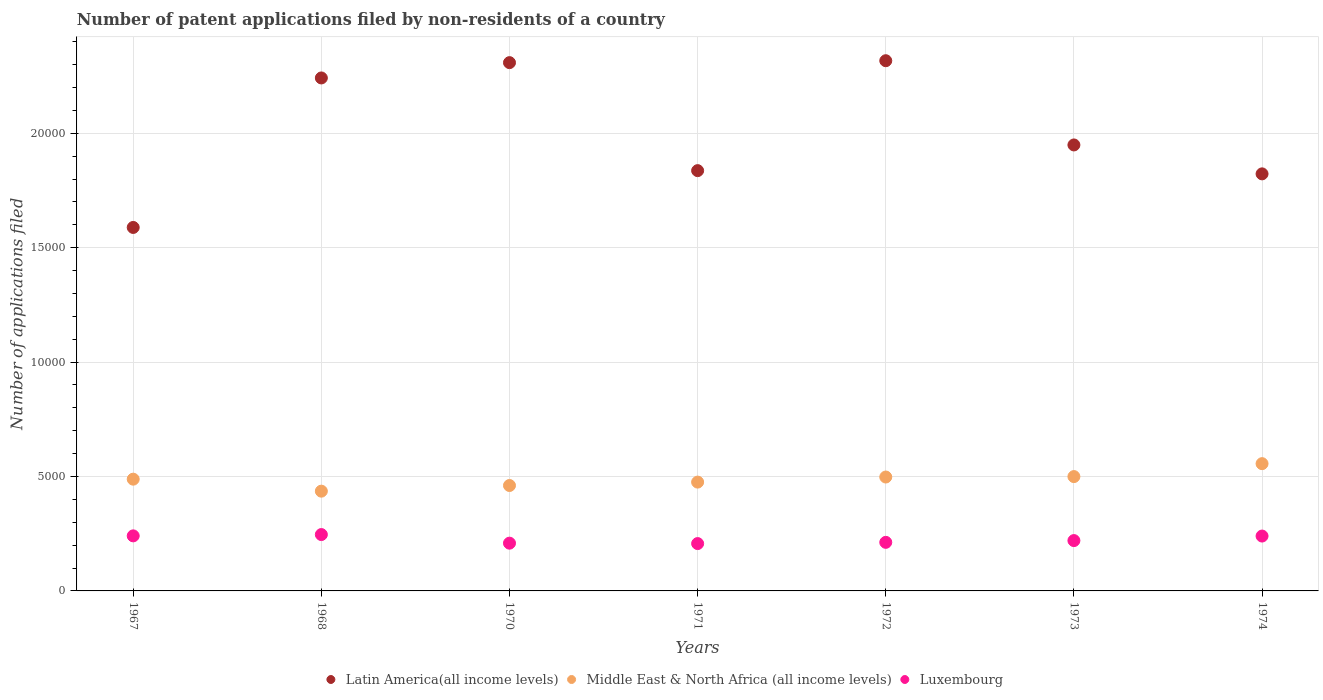Is the number of dotlines equal to the number of legend labels?
Ensure brevity in your answer.  Yes. What is the number of applications filed in Latin America(all income levels) in 1974?
Your answer should be very brief. 1.82e+04. Across all years, what is the maximum number of applications filed in Luxembourg?
Keep it short and to the point. 2463. Across all years, what is the minimum number of applications filed in Luxembourg?
Your answer should be very brief. 2069. In which year was the number of applications filed in Middle East & North Africa (all income levels) maximum?
Make the answer very short. 1974. In which year was the number of applications filed in Luxembourg minimum?
Provide a short and direct response. 1971. What is the total number of applications filed in Luxembourg in the graph?
Ensure brevity in your answer.  1.57e+04. What is the difference between the number of applications filed in Middle East & North Africa (all income levels) in 1973 and that in 1974?
Offer a terse response. -565. What is the difference between the number of applications filed in Luxembourg in 1967 and the number of applications filed in Middle East & North Africa (all income levels) in 1972?
Your answer should be very brief. -2572. What is the average number of applications filed in Middle East & North Africa (all income levels) per year?
Make the answer very short. 4877.71. In the year 1970, what is the difference between the number of applications filed in Middle East & North Africa (all income levels) and number of applications filed in Latin America(all income levels)?
Give a very brief answer. -1.85e+04. In how many years, is the number of applications filed in Latin America(all income levels) greater than 14000?
Your answer should be very brief. 7. What is the ratio of the number of applications filed in Luxembourg in 1967 to that in 1972?
Offer a terse response. 1.13. What is the difference between the highest and the lowest number of applications filed in Middle East & North Africa (all income levels)?
Offer a very short reply. 1202. Is it the case that in every year, the sum of the number of applications filed in Latin America(all income levels) and number of applications filed in Middle East & North Africa (all income levels)  is greater than the number of applications filed in Luxembourg?
Keep it short and to the point. Yes. Is the number of applications filed in Latin America(all income levels) strictly less than the number of applications filed in Middle East & North Africa (all income levels) over the years?
Your response must be concise. No. What is the difference between two consecutive major ticks on the Y-axis?
Your answer should be very brief. 5000. Are the values on the major ticks of Y-axis written in scientific E-notation?
Keep it short and to the point. No. Does the graph contain any zero values?
Make the answer very short. No. Where does the legend appear in the graph?
Your answer should be very brief. Bottom center. How many legend labels are there?
Your response must be concise. 3. What is the title of the graph?
Your answer should be compact. Number of patent applications filed by non-residents of a country. What is the label or title of the X-axis?
Offer a terse response. Years. What is the label or title of the Y-axis?
Offer a very short reply. Number of applications filed. What is the Number of applications filed in Latin America(all income levels) in 1967?
Ensure brevity in your answer.  1.59e+04. What is the Number of applications filed in Middle East & North Africa (all income levels) in 1967?
Offer a very short reply. 4884. What is the Number of applications filed of Luxembourg in 1967?
Offer a very short reply. 2406. What is the Number of applications filed in Latin America(all income levels) in 1968?
Give a very brief answer. 2.24e+04. What is the Number of applications filed in Middle East & North Africa (all income levels) in 1968?
Keep it short and to the point. 4360. What is the Number of applications filed of Luxembourg in 1968?
Provide a succinct answer. 2463. What is the Number of applications filed of Latin America(all income levels) in 1970?
Provide a short and direct response. 2.31e+04. What is the Number of applications filed of Middle East & North Africa (all income levels) in 1970?
Your answer should be compact. 4607. What is the Number of applications filed in Luxembourg in 1970?
Offer a terse response. 2087. What is the Number of applications filed of Latin America(all income levels) in 1971?
Offer a terse response. 1.84e+04. What is the Number of applications filed in Middle East & North Africa (all income levels) in 1971?
Provide a short and direct response. 4756. What is the Number of applications filed of Luxembourg in 1971?
Provide a short and direct response. 2069. What is the Number of applications filed of Latin America(all income levels) in 1972?
Offer a very short reply. 2.32e+04. What is the Number of applications filed in Middle East & North Africa (all income levels) in 1972?
Your answer should be compact. 4978. What is the Number of applications filed of Luxembourg in 1972?
Your answer should be compact. 2123. What is the Number of applications filed of Latin America(all income levels) in 1973?
Give a very brief answer. 1.95e+04. What is the Number of applications filed of Middle East & North Africa (all income levels) in 1973?
Your answer should be very brief. 4997. What is the Number of applications filed of Luxembourg in 1973?
Provide a short and direct response. 2200. What is the Number of applications filed of Latin America(all income levels) in 1974?
Keep it short and to the point. 1.82e+04. What is the Number of applications filed in Middle East & North Africa (all income levels) in 1974?
Give a very brief answer. 5562. What is the Number of applications filed in Luxembourg in 1974?
Provide a succinct answer. 2398. Across all years, what is the maximum Number of applications filed in Latin America(all income levels)?
Your answer should be very brief. 2.32e+04. Across all years, what is the maximum Number of applications filed in Middle East & North Africa (all income levels)?
Make the answer very short. 5562. Across all years, what is the maximum Number of applications filed in Luxembourg?
Your answer should be compact. 2463. Across all years, what is the minimum Number of applications filed of Latin America(all income levels)?
Ensure brevity in your answer.  1.59e+04. Across all years, what is the minimum Number of applications filed of Middle East & North Africa (all income levels)?
Give a very brief answer. 4360. Across all years, what is the minimum Number of applications filed in Luxembourg?
Your response must be concise. 2069. What is the total Number of applications filed in Latin America(all income levels) in the graph?
Provide a short and direct response. 1.41e+05. What is the total Number of applications filed in Middle East & North Africa (all income levels) in the graph?
Keep it short and to the point. 3.41e+04. What is the total Number of applications filed of Luxembourg in the graph?
Offer a terse response. 1.57e+04. What is the difference between the Number of applications filed of Latin America(all income levels) in 1967 and that in 1968?
Keep it short and to the point. -6534. What is the difference between the Number of applications filed of Middle East & North Africa (all income levels) in 1967 and that in 1968?
Provide a short and direct response. 524. What is the difference between the Number of applications filed in Luxembourg in 1967 and that in 1968?
Offer a very short reply. -57. What is the difference between the Number of applications filed of Latin America(all income levels) in 1967 and that in 1970?
Ensure brevity in your answer.  -7203. What is the difference between the Number of applications filed in Middle East & North Africa (all income levels) in 1967 and that in 1970?
Make the answer very short. 277. What is the difference between the Number of applications filed in Luxembourg in 1967 and that in 1970?
Offer a terse response. 319. What is the difference between the Number of applications filed in Latin America(all income levels) in 1967 and that in 1971?
Your response must be concise. -2483. What is the difference between the Number of applications filed in Middle East & North Africa (all income levels) in 1967 and that in 1971?
Give a very brief answer. 128. What is the difference between the Number of applications filed in Luxembourg in 1967 and that in 1971?
Ensure brevity in your answer.  337. What is the difference between the Number of applications filed in Latin America(all income levels) in 1967 and that in 1972?
Make the answer very short. -7287. What is the difference between the Number of applications filed in Middle East & North Africa (all income levels) in 1967 and that in 1972?
Ensure brevity in your answer.  -94. What is the difference between the Number of applications filed of Luxembourg in 1967 and that in 1972?
Ensure brevity in your answer.  283. What is the difference between the Number of applications filed of Latin America(all income levels) in 1967 and that in 1973?
Give a very brief answer. -3606. What is the difference between the Number of applications filed in Middle East & North Africa (all income levels) in 1967 and that in 1973?
Your answer should be very brief. -113. What is the difference between the Number of applications filed in Luxembourg in 1967 and that in 1973?
Provide a short and direct response. 206. What is the difference between the Number of applications filed in Latin America(all income levels) in 1967 and that in 1974?
Keep it short and to the point. -2342. What is the difference between the Number of applications filed of Middle East & North Africa (all income levels) in 1967 and that in 1974?
Keep it short and to the point. -678. What is the difference between the Number of applications filed in Latin America(all income levels) in 1968 and that in 1970?
Ensure brevity in your answer.  -669. What is the difference between the Number of applications filed in Middle East & North Africa (all income levels) in 1968 and that in 1970?
Provide a short and direct response. -247. What is the difference between the Number of applications filed of Luxembourg in 1968 and that in 1970?
Provide a short and direct response. 376. What is the difference between the Number of applications filed in Latin America(all income levels) in 1968 and that in 1971?
Provide a short and direct response. 4051. What is the difference between the Number of applications filed of Middle East & North Africa (all income levels) in 1968 and that in 1971?
Give a very brief answer. -396. What is the difference between the Number of applications filed in Luxembourg in 1968 and that in 1971?
Provide a short and direct response. 394. What is the difference between the Number of applications filed of Latin America(all income levels) in 1968 and that in 1972?
Provide a succinct answer. -753. What is the difference between the Number of applications filed in Middle East & North Africa (all income levels) in 1968 and that in 1972?
Provide a succinct answer. -618. What is the difference between the Number of applications filed of Luxembourg in 1968 and that in 1972?
Ensure brevity in your answer.  340. What is the difference between the Number of applications filed of Latin America(all income levels) in 1968 and that in 1973?
Your answer should be compact. 2928. What is the difference between the Number of applications filed in Middle East & North Africa (all income levels) in 1968 and that in 1973?
Make the answer very short. -637. What is the difference between the Number of applications filed in Luxembourg in 1968 and that in 1973?
Your answer should be compact. 263. What is the difference between the Number of applications filed of Latin America(all income levels) in 1968 and that in 1974?
Make the answer very short. 4192. What is the difference between the Number of applications filed of Middle East & North Africa (all income levels) in 1968 and that in 1974?
Provide a short and direct response. -1202. What is the difference between the Number of applications filed of Luxembourg in 1968 and that in 1974?
Give a very brief answer. 65. What is the difference between the Number of applications filed in Latin America(all income levels) in 1970 and that in 1971?
Give a very brief answer. 4720. What is the difference between the Number of applications filed of Middle East & North Africa (all income levels) in 1970 and that in 1971?
Provide a short and direct response. -149. What is the difference between the Number of applications filed in Luxembourg in 1970 and that in 1971?
Your answer should be very brief. 18. What is the difference between the Number of applications filed in Latin America(all income levels) in 1970 and that in 1972?
Your answer should be very brief. -84. What is the difference between the Number of applications filed in Middle East & North Africa (all income levels) in 1970 and that in 1972?
Make the answer very short. -371. What is the difference between the Number of applications filed in Luxembourg in 1970 and that in 1972?
Offer a terse response. -36. What is the difference between the Number of applications filed in Latin America(all income levels) in 1970 and that in 1973?
Give a very brief answer. 3597. What is the difference between the Number of applications filed of Middle East & North Africa (all income levels) in 1970 and that in 1973?
Give a very brief answer. -390. What is the difference between the Number of applications filed of Luxembourg in 1970 and that in 1973?
Your response must be concise. -113. What is the difference between the Number of applications filed of Latin America(all income levels) in 1970 and that in 1974?
Ensure brevity in your answer.  4861. What is the difference between the Number of applications filed in Middle East & North Africa (all income levels) in 1970 and that in 1974?
Your response must be concise. -955. What is the difference between the Number of applications filed of Luxembourg in 1970 and that in 1974?
Your answer should be compact. -311. What is the difference between the Number of applications filed in Latin America(all income levels) in 1971 and that in 1972?
Give a very brief answer. -4804. What is the difference between the Number of applications filed in Middle East & North Africa (all income levels) in 1971 and that in 1972?
Offer a terse response. -222. What is the difference between the Number of applications filed of Luxembourg in 1971 and that in 1972?
Provide a short and direct response. -54. What is the difference between the Number of applications filed of Latin America(all income levels) in 1971 and that in 1973?
Give a very brief answer. -1123. What is the difference between the Number of applications filed in Middle East & North Africa (all income levels) in 1971 and that in 1973?
Keep it short and to the point. -241. What is the difference between the Number of applications filed in Luxembourg in 1971 and that in 1973?
Offer a very short reply. -131. What is the difference between the Number of applications filed in Latin America(all income levels) in 1971 and that in 1974?
Your answer should be compact. 141. What is the difference between the Number of applications filed in Middle East & North Africa (all income levels) in 1971 and that in 1974?
Offer a very short reply. -806. What is the difference between the Number of applications filed of Luxembourg in 1971 and that in 1974?
Make the answer very short. -329. What is the difference between the Number of applications filed of Latin America(all income levels) in 1972 and that in 1973?
Make the answer very short. 3681. What is the difference between the Number of applications filed of Middle East & North Africa (all income levels) in 1972 and that in 1973?
Make the answer very short. -19. What is the difference between the Number of applications filed of Luxembourg in 1972 and that in 1973?
Give a very brief answer. -77. What is the difference between the Number of applications filed of Latin America(all income levels) in 1972 and that in 1974?
Make the answer very short. 4945. What is the difference between the Number of applications filed of Middle East & North Africa (all income levels) in 1972 and that in 1974?
Offer a very short reply. -584. What is the difference between the Number of applications filed in Luxembourg in 1972 and that in 1974?
Make the answer very short. -275. What is the difference between the Number of applications filed of Latin America(all income levels) in 1973 and that in 1974?
Offer a very short reply. 1264. What is the difference between the Number of applications filed of Middle East & North Africa (all income levels) in 1973 and that in 1974?
Your response must be concise. -565. What is the difference between the Number of applications filed of Luxembourg in 1973 and that in 1974?
Keep it short and to the point. -198. What is the difference between the Number of applications filed of Latin America(all income levels) in 1967 and the Number of applications filed of Middle East & North Africa (all income levels) in 1968?
Make the answer very short. 1.15e+04. What is the difference between the Number of applications filed of Latin America(all income levels) in 1967 and the Number of applications filed of Luxembourg in 1968?
Ensure brevity in your answer.  1.34e+04. What is the difference between the Number of applications filed in Middle East & North Africa (all income levels) in 1967 and the Number of applications filed in Luxembourg in 1968?
Provide a succinct answer. 2421. What is the difference between the Number of applications filed in Latin America(all income levels) in 1967 and the Number of applications filed in Middle East & North Africa (all income levels) in 1970?
Keep it short and to the point. 1.13e+04. What is the difference between the Number of applications filed in Latin America(all income levels) in 1967 and the Number of applications filed in Luxembourg in 1970?
Make the answer very short. 1.38e+04. What is the difference between the Number of applications filed in Middle East & North Africa (all income levels) in 1967 and the Number of applications filed in Luxembourg in 1970?
Ensure brevity in your answer.  2797. What is the difference between the Number of applications filed of Latin America(all income levels) in 1967 and the Number of applications filed of Middle East & North Africa (all income levels) in 1971?
Make the answer very short. 1.11e+04. What is the difference between the Number of applications filed of Latin America(all income levels) in 1967 and the Number of applications filed of Luxembourg in 1971?
Provide a succinct answer. 1.38e+04. What is the difference between the Number of applications filed of Middle East & North Africa (all income levels) in 1967 and the Number of applications filed of Luxembourg in 1971?
Provide a succinct answer. 2815. What is the difference between the Number of applications filed of Latin America(all income levels) in 1967 and the Number of applications filed of Middle East & North Africa (all income levels) in 1972?
Ensure brevity in your answer.  1.09e+04. What is the difference between the Number of applications filed of Latin America(all income levels) in 1967 and the Number of applications filed of Luxembourg in 1972?
Provide a succinct answer. 1.38e+04. What is the difference between the Number of applications filed in Middle East & North Africa (all income levels) in 1967 and the Number of applications filed in Luxembourg in 1972?
Provide a short and direct response. 2761. What is the difference between the Number of applications filed of Latin America(all income levels) in 1967 and the Number of applications filed of Middle East & North Africa (all income levels) in 1973?
Provide a short and direct response. 1.09e+04. What is the difference between the Number of applications filed of Latin America(all income levels) in 1967 and the Number of applications filed of Luxembourg in 1973?
Your answer should be compact. 1.37e+04. What is the difference between the Number of applications filed in Middle East & North Africa (all income levels) in 1967 and the Number of applications filed in Luxembourg in 1973?
Give a very brief answer. 2684. What is the difference between the Number of applications filed in Latin America(all income levels) in 1967 and the Number of applications filed in Middle East & North Africa (all income levels) in 1974?
Your answer should be very brief. 1.03e+04. What is the difference between the Number of applications filed of Latin America(all income levels) in 1967 and the Number of applications filed of Luxembourg in 1974?
Your answer should be compact. 1.35e+04. What is the difference between the Number of applications filed of Middle East & North Africa (all income levels) in 1967 and the Number of applications filed of Luxembourg in 1974?
Provide a succinct answer. 2486. What is the difference between the Number of applications filed in Latin America(all income levels) in 1968 and the Number of applications filed in Middle East & North Africa (all income levels) in 1970?
Offer a very short reply. 1.78e+04. What is the difference between the Number of applications filed of Latin America(all income levels) in 1968 and the Number of applications filed of Luxembourg in 1970?
Provide a succinct answer. 2.03e+04. What is the difference between the Number of applications filed of Middle East & North Africa (all income levels) in 1968 and the Number of applications filed of Luxembourg in 1970?
Offer a very short reply. 2273. What is the difference between the Number of applications filed of Latin America(all income levels) in 1968 and the Number of applications filed of Middle East & North Africa (all income levels) in 1971?
Offer a terse response. 1.77e+04. What is the difference between the Number of applications filed in Latin America(all income levels) in 1968 and the Number of applications filed in Luxembourg in 1971?
Your answer should be compact. 2.04e+04. What is the difference between the Number of applications filed in Middle East & North Africa (all income levels) in 1968 and the Number of applications filed in Luxembourg in 1971?
Offer a terse response. 2291. What is the difference between the Number of applications filed in Latin America(all income levels) in 1968 and the Number of applications filed in Middle East & North Africa (all income levels) in 1972?
Make the answer very short. 1.74e+04. What is the difference between the Number of applications filed of Latin America(all income levels) in 1968 and the Number of applications filed of Luxembourg in 1972?
Provide a short and direct response. 2.03e+04. What is the difference between the Number of applications filed in Middle East & North Africa (all income levels) in 1968 and the Number of applications filed in Luxembourg in 1972?
Your answer should be compact. 2237. What is the difference between the Number of applications filed in Latin America(all income levels) in 1968 and the Number of applications filed in Middle East & North Africa (all income levels) in 1973?
Offer a terse response. 1.74e+04. What is the difference between the Number of applications filed in Latin America(all income levels) in 1968 and the Number of applications filed in Luxembourg in 1973?
Make the answer very short. 2.02e+04. What is the difference between the Number of applications filed in Middle East & North Africa (all income levels) in 1968 and the Number of applications filed in Luxembourg in 1973?
Make the answer very short. 2160. What is the difference between the Number of applications filed in Latin America(all income levels) in 1968 and the Number of applications filed in Middle East & North Africa (all income levels) in 1974?
Offer a terse response. 1.69e+04. What is the difference between the Number of applications filed in Latin America(all income levels) in 1968 and the Number of applications filed in Luxembourg in 1974?
Give a very brief answer. 2.00e+04. What is the difference between the Number of applications filed of Middle East & North Africa (all income levels) in 1968 and the Number of applications filed of Luxembourg in 1974?
Provide a succinct answer. 1962. What is the difference between the Number of applications filed of Latin America(all income levels) in 1970 and the Number of applications filed of Middle East & North Africa (all income levels) in 1971?
Offer a terse response. 1.83e+04. What is the difference between the Number of applications filed of Latin America(all income levels) in 1970 and the Number of applications filed of Luxembourg in 1971?
Offer a terse response. 2.10e+04. What is the difference between the Number of applications filed of Middle East & North Africa (all income levels) in 1970 and the Number of applications filed of Luxembourg in 1971?
Keep it short and to the point. 2538. What is the difference between the Number of applications filed in Latin America(all income levels) in 1970 and the Number of applications filed in Middle East & North Africa (all income levels) in 1972?
Your answer should be very brief. 1.81e+04. What is the difference between the Number of applications filed of Latin America(all income levels) in 1970 and the Number of applications filed of Luxembourg in 1972?
Your answer should be very brief. 2.10e+04. What is the difference between the Number of applications filed in Middle East & North Africa (all income levels) in 1970 and the Number of applications filed in Luxembourg in 1972?
Your response must be concise. 2484. What is the difference between the Number of applications filed in Latin America(all income levels) in 1970 and the Number of applications filed in Middle East & North Africa (all income levels) in 1973?
Offer a terse response. 1.81e+04. What is the difference between the Number of applications filed in Latin America(all income levels) in 1970 and the Number of applications filed in Luxembourg in 1973?
Offer a terse response. 2.09e+04. What is the difference between the Number of applications filed of Middle East & North Africa (all income levels) in 1970 and the Number of applications filed of Luxembourg in 1973?
Offer a terse response. 2407. What is the difference between the Number of applications filed of Latin America(all income levels) in 1970 and the Number of applications filed of Middle East & North Africa (all income levels) in 1974?
Provide a short and direct response. 1.75e+04. What is the difference between the Number of applications filed of Latin America(all income levels) in 1970 and the Number of applications filed of Luxembourg in 1974?
Your response must be concise. 2.07e+04. What is the difference between the Number of applications filed in Middle East & North Africa (all income levels) in 1970 and the Number of applications filed in Luxembourg in 1974?
Give a very brief answer. 2209. What is the difference between the Number of applications filed of Latin America(all income levels) in 1971 and the Number of applications filed of Middle East & North Africa (all income levels) in 1972?
Your response must be concise. 1.34e+04. What is the difference between the Number of applications filed in Latin America(all income levels) in 1971 and the Number of applications filed in Luxembourg in 1972?
Provide a succinct answer. 1.62e+04. What is the difference between the Number of applications filed of Middle East & North Africa (all income levels) in 1971 and the Number of applications filed of Luxembourg in 1972?
Offer a very short reply. 2633. What is the difference between the Number of applications filed in Latin America(all income levels) in 1971 and the Number of applications filed in Middle East & North Africa (all income levels) in 1973?
Provide a short and direct response. 1.34e+04. What is the difference between the Number of applications filed of Latin America(all income levels) in 1971 and the Number of applications filed of Luxembourg in 1973?
Ensure brevity in your answer.  1.62e+04. What is the difference between the Number of applications filed in Middle East & North Africa (all income levels) in 1971 and the Number of applications filed in Luxembourg in 1973?
Keep it short and to the point. 2556. What is the difference between the Number of applications filed of Latin America(all income levels) in 1971 and the Number of applications filed of Middle East & North Africa (all income levels) in 1974?
Provide a short and direct response. 1.28e+04. What is the difference between the Number of applications filed of Latin America(all income levels) in 1971 and the Number of applications filed of Luxembourg in 1974?
Give a very brief answer. 1.60e+04. What is the difference between the Number of applications filed in Middle East & North Africa (all income levels) in 1971 and the Number of applications filed in Luxembourg in 1974?
Your response must be concise. 2358. What is the difference between the Number of applications filed of Latin America(all income levels) in 1972 and the Number of applications filed of Middle East & North Africa (all income levels) in 1973?
Your response must be concise. 1.82e+04. What is the difference between the Number of applications filed of Latin America(all income levels) in 1972 and the Number of applications filed of Luxembourg in 1973?
Your answer should be very brief. 2.10e+04. What is the difference between the Number of applications filed of Middle East & North Africa (all income levels) in 1972 and the Number of applications filed of Luxembourg in 1973?
Give a very brief answer. 2778. What is the difference between the Number of applications filed of Latin America(all income levels) in 1972 and the Number of applications filed of Middle East & North Africa (all income levels) in 1974?
Your answer should be compact. 1.76e+04. What is the difference between the Number of applications filed in Latin America(all income levels) in 1972 and the Number of applications filed in Luxembourg in 1974?
Make the answer very short. 2.08e+04. What is the difference between the Number of applications filed in Middle East & North Africa (all income levels) in 1972 and the Number of applications filed in Luxembourg in 1974?
Offer a terse response. 2580. What is the difference between the Number of applications filed of Latin America(all income levels) in 1973 and the Number of applications filed of Middle East & North Africa (all income levels) in 1974?
Provide a succinct answer. 1.39e+04. What is the difference between the Number of applications filed in Latin America(all income levels) in 1973 and the Number of applications filed in Luxembourg in 1974?
Offer a terse response. 1.71e+04. What is the difference between the Number of applications filed of Middle East & North Africa (all income levels) in 1973 and the Number of applications filed of Luxembourg in 1974?
Your response must be concise. 2599. What is the average Number of applications filed of Latin America(all income levels) per year?
Your response must be concise. 2.01e+04. What is the average Number of applications filed of Middle East & North Africa (all income levels) per year?
Offer a very short reply. 4877.71. What is the average Number of applications filed in Luxembourg per year?
Offer a terse response. 2249.43. In the year 1967, what is the difference between the Number of applications filed of Latin America(all income levels) and Number of applications filed of Middle East & North Africa (all income levels)?
Keep it short and to the point. 1.10e+04. In the year 1967, what is the difference between the Number of applications filed in Latin America(all income levels) and Number of applications filed in Luxembourg?
Make the answer very short. 1.35e+04. In the year 1967, what is the difference between the Number of applications filed in Middle East & North Africa (all income levels) and Number of applications filed in Luxembourg?
Keep it short and to the point. 2478. In the year 1968, what is the difference between the Number of applications filed in Latin America(all income levels) and Number of applications filed in Middle East & North Africa (all income levels)?
Your answer should be compact. 1.81e+04. In the year 1968, what is the difference between the Number of applications filed in Latin America(all income levels) and Number of applications filed in Luxembourg?
Give a very brief answer. 2.00e+04. In the year 1968, what is the difference between the Number of applications filed of Middle East & North Africa (all income levels) and Number of applications filed of Luxembourg?
Your response must be concise. 1897. In the year 1970, what is the difference between the Number of applications filed in Latin America(all income levels) and Number of applications filed in Middle East & North Africa (all income levels)?
Your response must be concise. 1.85e+04. In the year 1970, what is the difference between the Number of applications filed in Latin America(all income levels) and Number of applications filed in Luxembourg?
Give a very brief answer. 2.10e+04. In the year 1970, what is the difference between the Number of applications filed in Middle East & North Africa (all income levels) and Number of applications filed in Luxembourg?
Your response must be concise. 2520. In the year 1971, what is the difference between the Number of applications filed of Latin America(all income levels) and Number of applications filed of Middle East & North Africa (all income levels)?
Offer a terse response. 1.36e+04. In the year 1971, what is the difference between the Number of applications filed in Latin America(all income levels) and Number of applications filed in Luxembourg?
Make the answer very short. 1.63e+04. In the year 1971, what is the difference between the Number of applications filed in Middle East & North Africa (all income levels) and Number of applications filed in Luxembourg?
Your answer should be compact. 2687. In the year 1972, what is the difference between the Number of applications filed of Latin America(all income levels) and Number of applications filed of Middle East & North Africa (all income levels)?
Give a very brief answer. 1.82e+04. In the year 1972, what is the difference between the Number of applications filed of Latin America(all income levels) and Number of applications filed of Luxembourg?
Your response must be concise. 2.10e+04. In the year 1972, what is the difference between the Number of applications filed in Middle East & North Africa (all income levels) and Number of applications filed in Luxembourg?
Provide a succinct answer. 2855. In the year 1973, what is the difference between the Number of applications filed of Latin America(all income levels) and Number of applications filed of Middle East & North Africa (all income levels)?
Offer a very short reply. 1.45e+04. In the year 1973, what is the difference between the Number of applications filed of Latin America(all income levels) and Number of applications filed of Luxembourg?
Ensure brevity in your answer.  1.73e+04. In the year 1973, what is the difference between the Number of applications filed of Middle East & North Africa (all income levels) and Number of applications filed of Luxembourg?
Make the answer very short. 2797. In the year 1974, what is the difference between the Number of applications filed in Latin America(all income levels) and Number of applications filed in Middle East & North Africa (all income levels)?
Make the answer very short. 1.27e+04. In the year 1974, what is the difference between the Number of applications filed in Latin America(all income levels) and Number of applications filed in Luxembourg?
Your answer should be very brief. 1.58e+04. In the year 1974, what is the difference between the Number of applications filed of Middle East & North Africa (all income levels) and Number of applications filed of Luxembourg?
Your response must be concise. 3164. What is the ratio of the Number of applications filed of Latin America(all income levels) in 1967 to that in 1968?
Keep it short and to the point. 0.71. What is the ratio of the Number of applications filed of Middle East & North Africa (all income levels) in 1967 to that in 1968?
Provide a succinct answer. 1.12. What is the ratio of the Number of applications filed of Luxembourg in 1967 to that in 1968?
Give a very brief answer. 0.98. What is the ratio of the Number of applications filed in Latin America(all income levels) in 1967 to that in 1970?
Your answer should be very brief. 0.69. What is the ratio of the Number of applications filed in Middle East & North Africa (all income levels) in 1967 to that in 1970?
Offer a very short reply. 1.06. What is the ratio of the Number of applications filed in Luxembourg in 1967 to that in 1970?
Offer a very short reply. 1.15. What is the ratio of the Number of applications filed in Latin America(all income levels) in 1967 to that in 1971?
Keep it short and to the point. 0.86. What is the ratio of the Number of applications filed of Middle East & North Africa (all income levels) in 1967 to that in 1971?
Make the answer very short. 1.03. What is the ratio of the Number of applications filed in Luxembourg in 1967 to that in 1971?
Keep it short and to the point. 1.16. What is the ratio of the Number of applications filed in Latin America(all income levels) in 1967 to that in 1972?
Your response must be concise. 0.69. What is the ratio of the Number of applications filed in Middle East & North Africa (all income levels) in 1967 to that in 1972?
Provide a short and direct response. 0.98. What is the ratio of the Number of applications filed in Luxembourg in 1967 to that in 1972?
Make the answer very short. 1.13. What is the ratio of the Number of applications filed of Latin America(all income levels) in 1967 to that in 1973?
Keep it short and to the point. 0.81. What is the ratio of the Number of applications filed of Middle East & North Africa (all income levels) in 1967 to that in 1973?
Ensure brevity in your answer.  0.98. What is the ratio of the Number of applications filed in Luxembourg in 1967 to that in 1973?
Keep it short and to the point. 1.09. What is the ratio of the Number of applications filed in Latin America(all income levels) in 1967 to that in 1974?
Offer a very short reply. 0.87. What is the ratio of the Number of applications filed of Middle East & North Africa (all income levels) in 1967 to that in 1974?
Make the answer very short. 0.88. What is the ratio of the Number of applications filed of Middle East & North Africa (all income levels) in 1968 to that in 1970?
Give a very brief answer. 0.95. What is the ratio of the Number of applications filed of Luxembourg in 1968 to that in 1970?
Provide a succinct answer. 1.18. What is the ratio of the Number of applications filed of Latin America(all income levels) in 1968 to that in 1971?
Ensure brevity in your answer.  1.22. What is the ratio of the Number of applications filed in Luxembourg in 1968 to that in 1971?
Provide a short and direct response. 1.19. What is the ratio of the Number of applications filed in Latin America(all income levels) in 1968 to that in 1972?
Provide a short and direct response. 0.97. What is the ratio of the Number of applications filed of Middle East & North Africa (all income levels) in 1968 to that in 1972?
Your response must be concise. 0.88. What is the ratio of the Number of applications filed of Luxembourg in 1968 to that in 1972?
Your answer should be compact. 1.16. What is the ratio of the Number of applications filed in Latin America(all income levels) in 1968 to that in 1973?
Your answer should be very brief. 1.15. What is the ratio of the Number of applications filed in Middle East & North Africa (all income levels) in 1968 to that in 1973?
Your response must be concise. 0.87. What is the ratio of the Number of applications filed of Luxembourg in 1968 to that in 1973?
Provide a short and direct response. 1.12. What is the ratio of the Number of applications filed of Latin America(all income levels) in 1968 to that in 1974?
Your answer should be compact. 1.23. What is the ratio of the Number of applications filed of Middle East & North Africa (all income levels) in 1968 to that in 1974?
Your answer should be very brief. 0.78. What is the ratio of the Number of applications filed in Luxembourg in 1968 to that in 1974?
Make the answer very short. 1.03. What is the ratio of the Number of applications filed of Latin America(all income levels) in 1970 to that in 1971?
Give a very brief answer. 1.26. What is the ratio of the Number of applications filed in Middle East & North Africa (all income levels) in 1970 to that in 1971?
Make the answer very short. 0.97. What is the ratio of the Number of applications filed of Luxembourg in 1970 to that in 1971?
Offer a very short reply. 1.01. What is the ratio of the Number of applications filed of Latin America(all income levels) in 1970 to that in 1972?
Your answer should be compact. 1. What is the ratio of the Number of applications filed of Middle East & North Africa (all income levels) in 1970 to that in 1972?
Give a very brief answer. 0.93. What is the ratio of the Number of applications filed of Latin America(all income levels) in 1970 to that in 1973?
Ensure brevity in your answer.  1.18. What is the ratio of the Number of applications filed of Middle East & North Africa (all income levels) in 1970 to that in 1973?
Give a very brief answer. 0.92. What is the ratio of the Number of applications filed in Luxembourg in 1970 to that in 1973?
Offer a terse response. 0.95. What is the ratio of the Number of applications filed of Latin America(all income levels) in 1970 to that in 1974?
Provide a short and direct response. 1.27. What is the ratio of the Number of applications filed of Middle East & North Africa (all income levels) in 1970 to that in 1974?
Ensure brevity in your answer.  0.83. What is the ratio of the Number of applications filed in Luxembourg in 1970 to that in 1974?
Ensure brevity in your answer.  0.87. What is the ratio of the Number of applications filed of Latin America(all income levels) in 1971 to that in 1972?
Keep it short and to the point. 0.79. What is the ratio of the Number of applications filed in Middle East & North Africa (all income levels) in 1971 to that in 1972?
Provide a succinct answer. 0.96. What is the ratio of the Number of applications filed in Luxembourg in 1971 to that in 1972?
Your answer should be compact. 0.97. What is the ratio of the Number of applications filed in Latin America(all income levels) in 1971 to that in 1973?
Offer a terse response. 0.94. What is the ratio of the Number of applications filed of Middle East & North Africa (all income levels) in 1971 to that in 1973?
Provide a short and direct response. 0.95. What is the ratio of the Number of applications filed in Luxembourg in 1971 to that in 1973?
Your answer should be very brief. 0.94. What is the ratio of the Number of applications filed in Latin America(all income levels) in 1971 to that in 1974?
Make the answer very short. 1.01. What is the ratio of the Number of applications filed in Middle East & North Africa (all income levels) in 1971 to that in 1974?
Provide a short and direct response. 0.86. What is the ratio of the Number of applications filed in Luxembourg in 1971 to that in 1974?
Offer a terse response. 0.86. What is the ratio of the Number of applications filed in Latin America(all income levels) in 1972 to that in 1973?
Your answer should be very brief. 1.19. What is the ratio of the Number of applications filed in Middle East & North Africa (all income levels) in 1972 to that in 1973?
Offer a terse response. 1. What is the ratio of the Number of applications filed in Latin America(all income levels) in 1972 to that in 1974?
Your answer should be very brief. 1.27. What is the ratio of the Number of applications filed in Middle East & North Africa (all income levels) in 1972 to that in 1974?
Ensure brevity in your answer.  0.9. What is the ratio of the Number of applications filed in Luxembourg in 1972 to that in 1974?
Provide a short and direct response. 0.89. What is the ratio of the Number of applications filed in Latin America(all income levels) in 1973 to that in 1974?
Your response must be concise. 1.07. What is the ratio of the Number of applications filed in Middle East & North Africa (all income levels) in 1973 to that in 1974?
Make the answer very short. 0.9. What is the ratio of the Number of applications filed in Luxembourg in 1973 to that in 1974?
Give a very brief answer. 0.92. What is the difference between the highest and the second highest Number of applications filed of Middle East & North Africa (all income levels)?
Ensure brevity in your answer.  565. What is the difference between the highest and the lowest Number of applications filed of Latin America(all income levels)?
Make the answer very short. 7287. What is the difference between the highest and the lowest Number of applications filed in Middle East & North Africa (all income levels)?
Offer a terse response. 1202. What is the difference between the highest and the lowest Number of applications filed in Luxembourg?
Offer a very short reply. 394. 